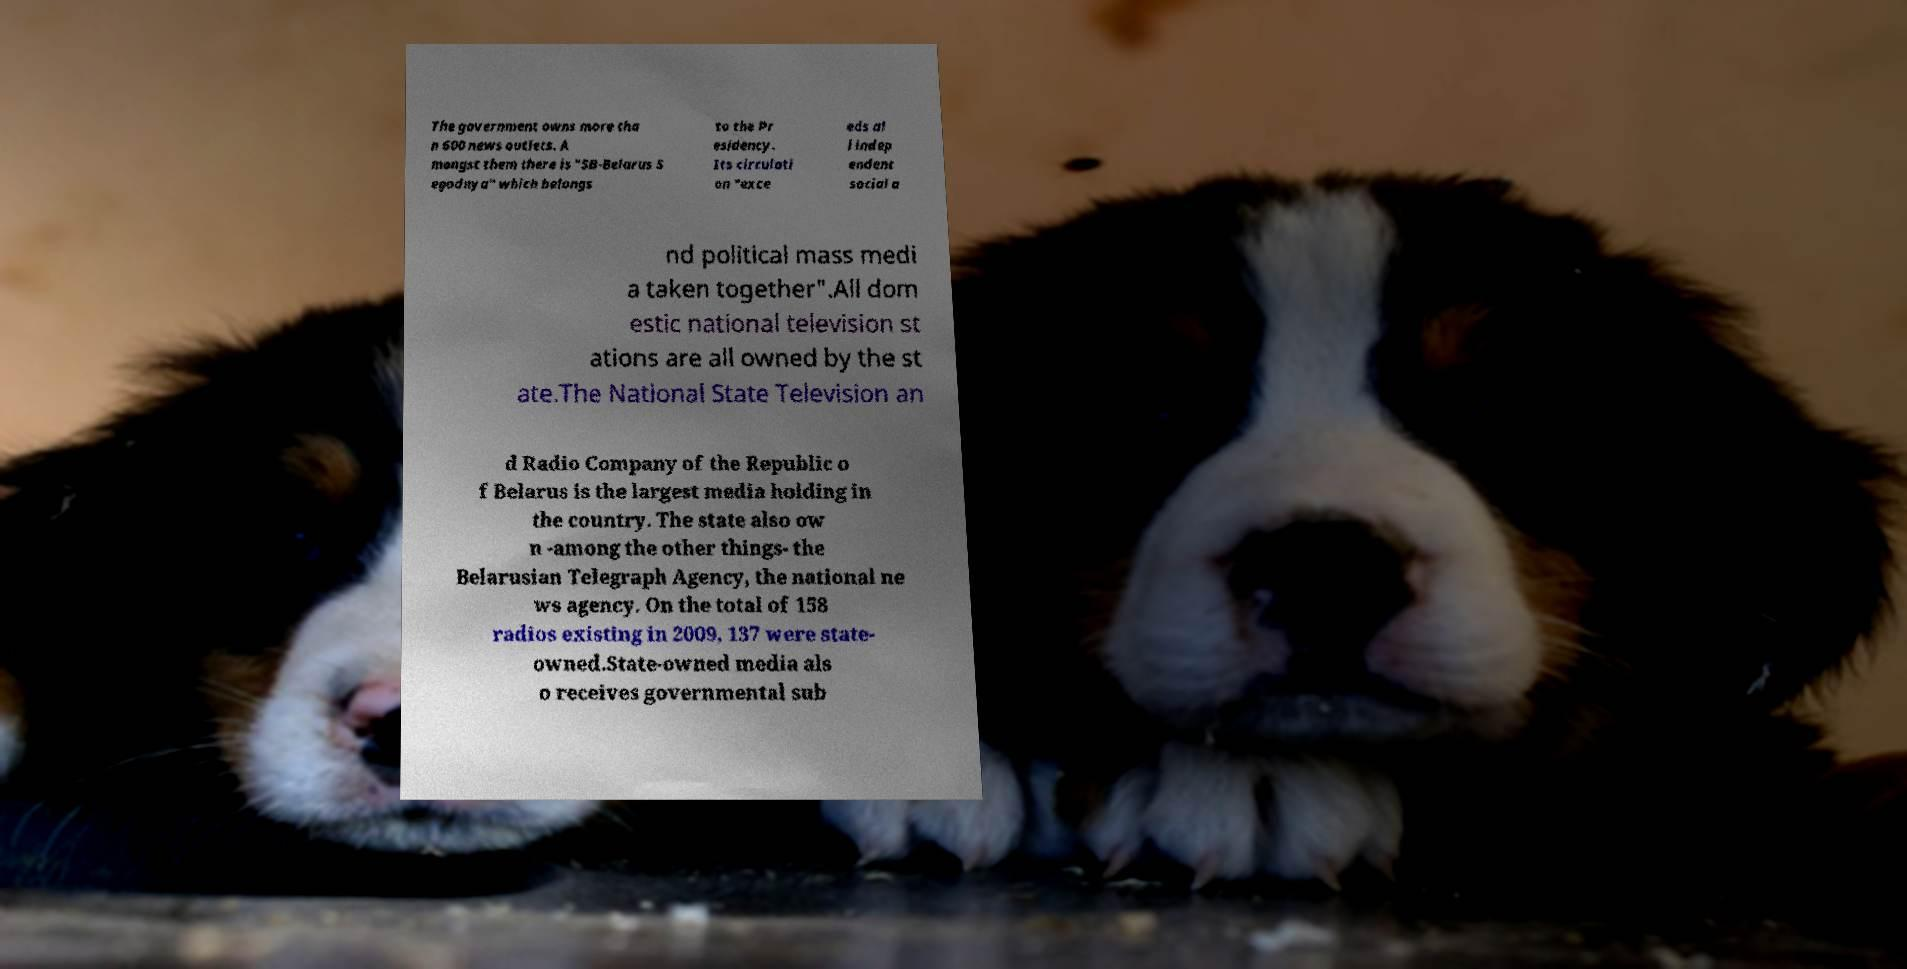For documentation purposes, I need the text within this image transcribed. Could you provide that? The government owns more tha n 600 news outlets. A mongst them there is "SB-Belarus S egodnya" which belongs to the Pr esidency. Its circulati on "exce eds al l indep endent social a nd political mass medi a taken together".All dom estic national television st ations are all owned by the st ate.The National State Television an d Radio Company of the Republic o f Belarus is the largest media holding in the country. The state also ow n -among the other things- the Belarusian Telegraph Agency, the national ne ws agency. On the total of 158 radios existing in 2009, 137 were state- owned.State-owned media als o receives governmental sub 